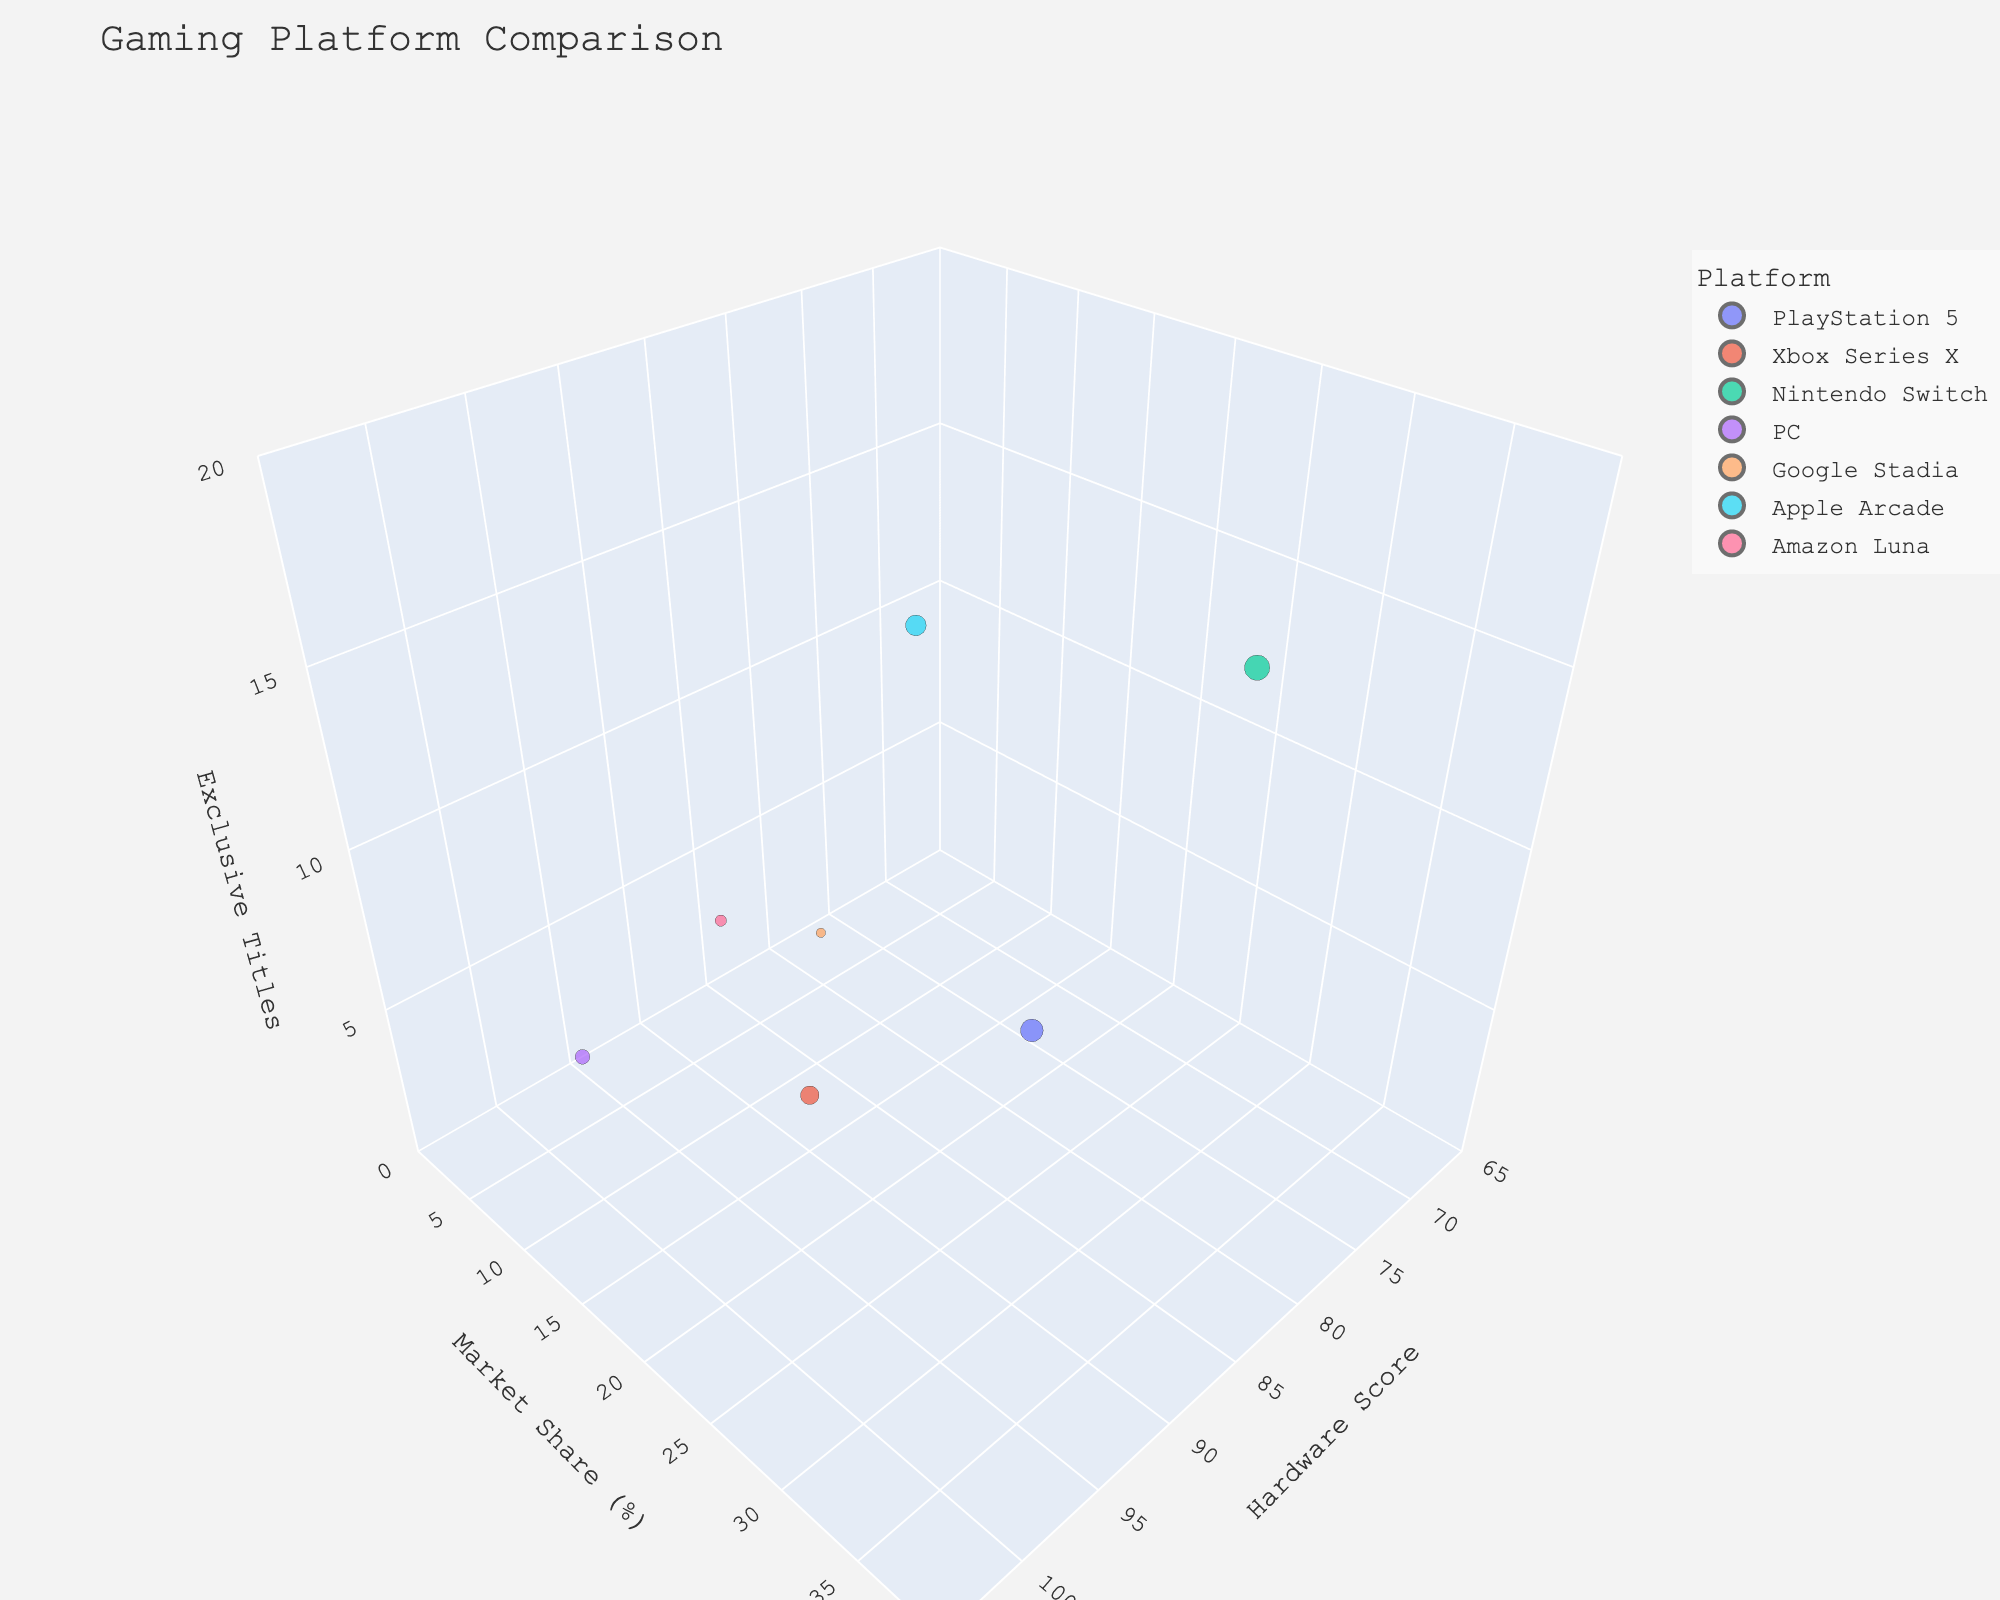What platform has the highest market share? The tallest bubble along the y-axis, representing the Market Share (%), indicates the platform with the highest market share. From the figure, it's the PlayStation 5.
Answer: PlayStation 5 Which platform has the highest Hardware Score? The bubble that is farthest along the x-axis indicates the highest Hardware Score. From the figure, it's the PC.
Answer: PC How many exclusive titles does the platform with the lowest market share have? The bubble closest to the bottom of the y-axis represents the platform with the lowest market share. From the figure, Amazon Luna has this position. Looking at the z-axis for this platform, it has 3 exclusive titles.
Answer: 3 Which platform has the largest bubble size? The largest bubble represents the platform with the highest number of exclusive titles, as bubble size is based on this metric. From the figure, the Nintendo Switch has the largest bubble.
Answer: Nintendo Switch What is the difference in market share between the platform with the highest number of exclusive titles and the one with the least? The Nintendo Switch has the highest exclusive titles, and Google Stadia has the least. The market share for Nintendo Switch is 30%, and for Google Stadia, it is 5%. The difference is 30% - 5% = 25%.
Answer: 25% Which platforms have a market share greater than 20%? Bubbles that are above the 20% mark on the y-axis qualify. These are PlayStation 5, Xbox Series X, and Nintendo Switch.
Answer: PlayStation 5, Xbox Series X, Nintendo Switch Is there any platform with a Hardware Score lower than 80? By examining the x-axis and locating bubbles to the left of the 80 mark, the platform found there is Apple Arcade.
Answer: Apple Arcade Which platform has more exclusive titles, PlayStation 5 or Xbox Series X? The vertical position (z-axis) of the bubbles indicate number of exclusive titles. PlayStation 5 has 12, while Xbox Series X has 8 exclusive titles, so PlayStation 5 has more.
Answer: PlayStation 5 What is the total number of exclusive titles for platforms with market shares less than 10%? The platforms with market shares under 10% are PC, Google Stadia, Apple Arcade, and Amazon Luna. Adding their exclusive titles: 5 (PC) + 2 (Google Stadia) + 10 (Apple Arcade) + 3 (Amazon Luna) = 20.
Answer: 20 Which platform has the most balanced performance in all three metrics? A balanced performance shows a moderate position in all three axes (Market Share, Hardware Score, Exclusive Titles). The Nintendo Switch seems most balanced with moderate to high values in all metrics.
Answer: Nintendo Switch 